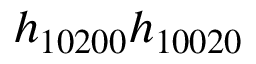<formula> <loc_0><loc_0><loc_500><loc_500>h _ { 1 0 2 0 0 } h _ { 1 0 0 2 0 }</formula> 